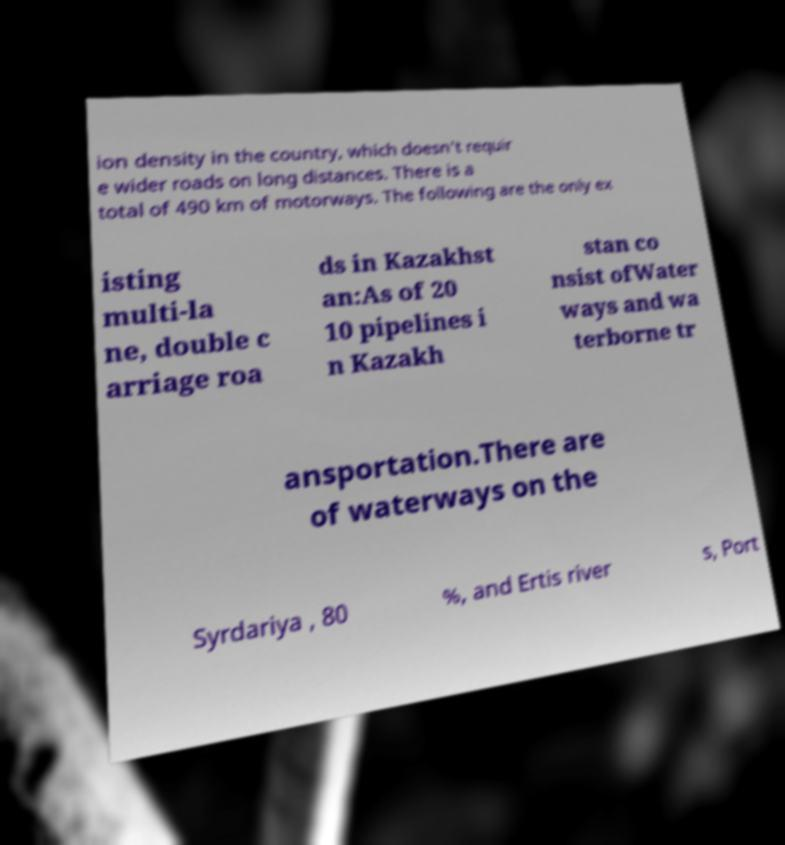Can you accurately transcribe the text from the provided image for me? ion density in the country, which doesn't requir e wider roads on long distances. There is a total of 490 km of motorways. The following are the only ex isting multi-la ne, double c arriage roa ds in Kazakhst an:As of 20 10 pipelines i n Kazakh stan co nsist ofWater ways and wa terborne tr ansportation.There are of waterways on the Syrdariya , 80 %, and Ertis river s, Port 